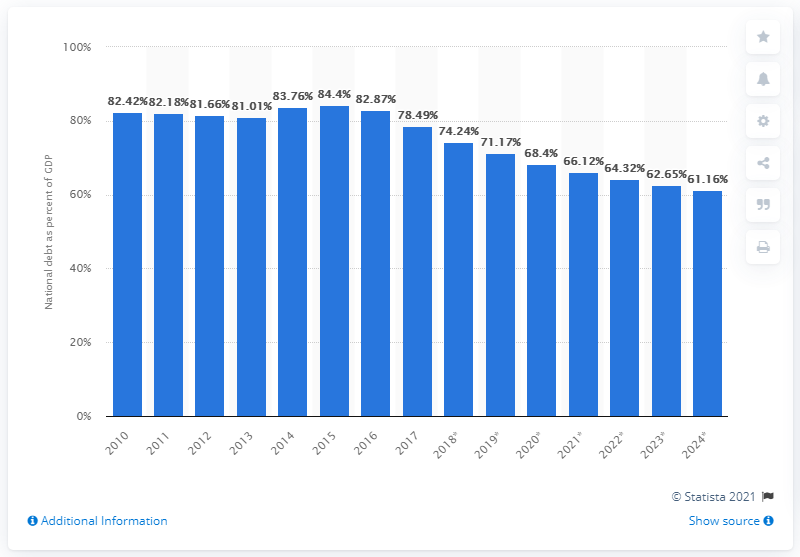Point out several critical features in this image. In 2017, the national debt of Austria accounted for approximately 78.49% of the country's Gross Domestic Product (GDP). 